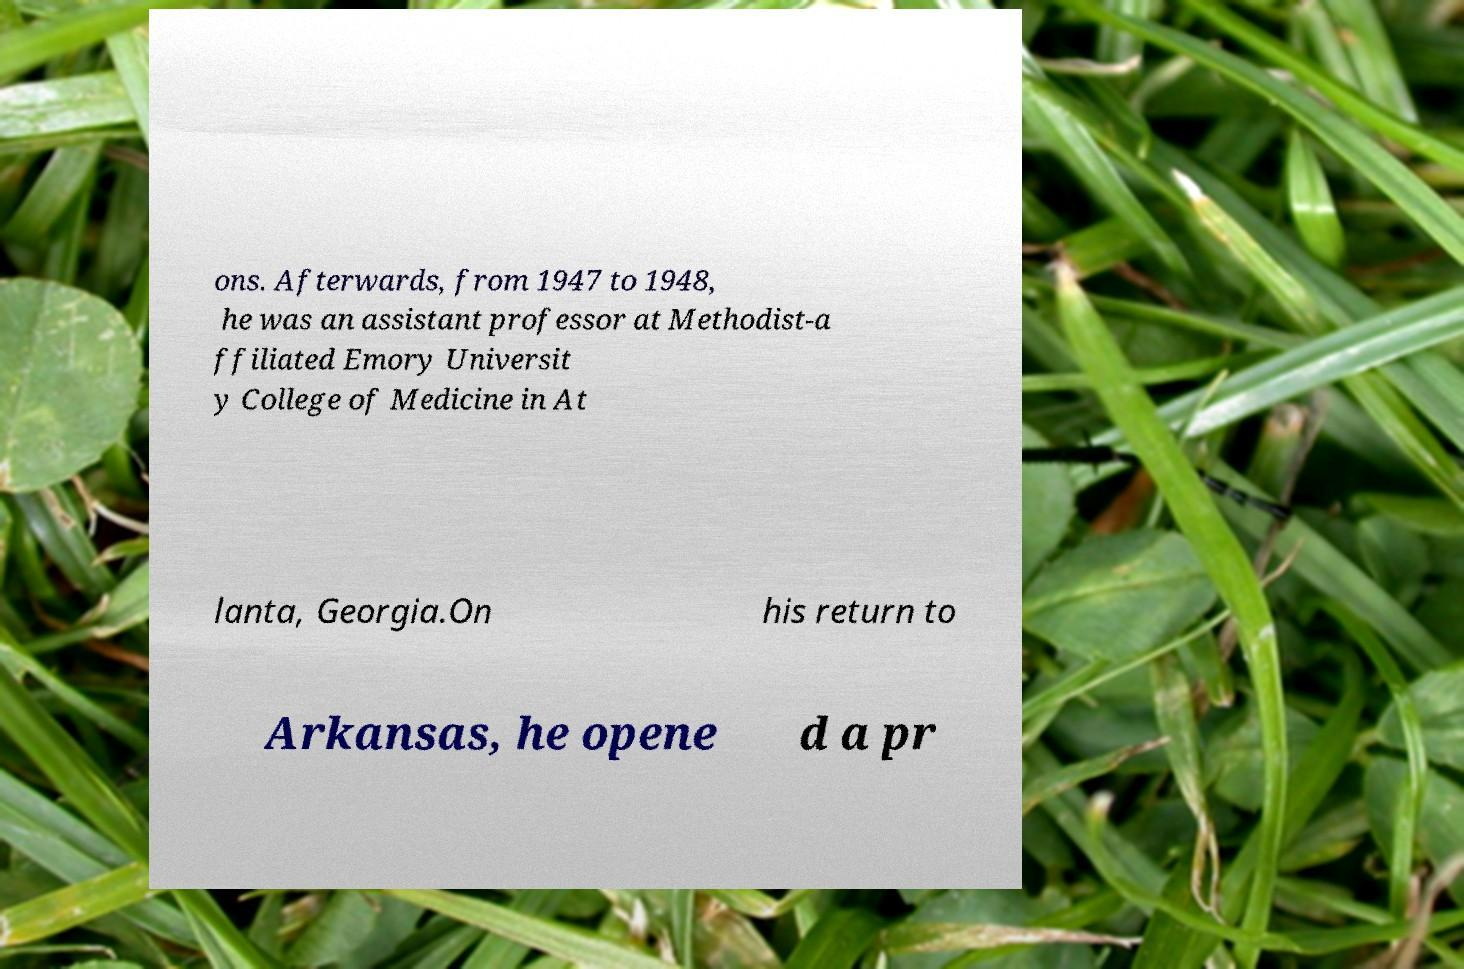Please identify and transcribe the text found in this image. ons. Afterwards, from 1947 to 1948, he was an assistant professor at Methodist-a ffiliated Emory Universit y College of Medicine in At lanta, Georgia.On his return to Arkansas, he opene d a pr 